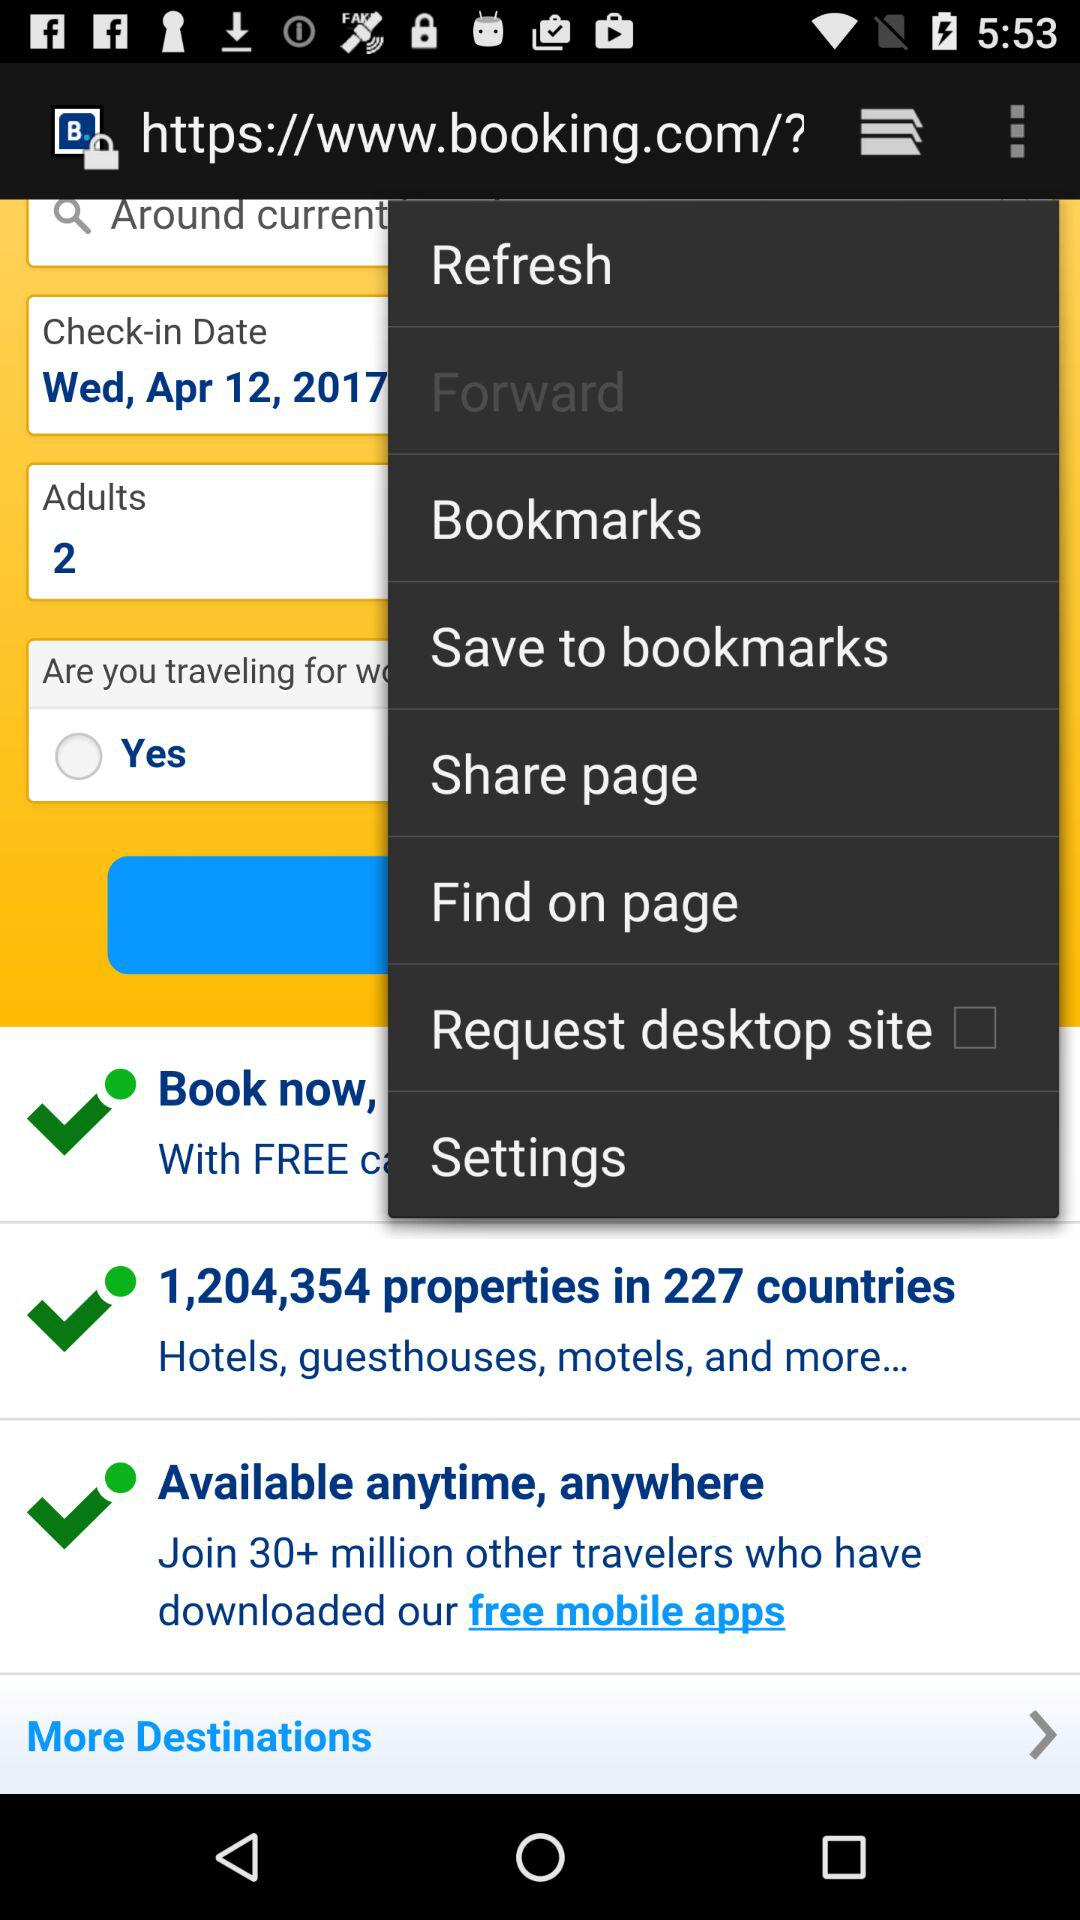How many countries are available?
Answer the question using a single word or phrase. 227 